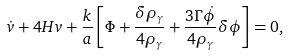Convert formula to latex. <formula><loc_0><loc_0><loc_500><loc_500>\dot { v } + 4 H v + \frac { k } { a } \left [ \Phi + \frac { \delta \rho _ { \gamma } } { 4 \rho _ { \gamma } } + \frac { 3 \Gamma \dot { \phi } } { 4 \rho _ { \gamma } } \delta \phi \right ] = 0 ,</formula> 